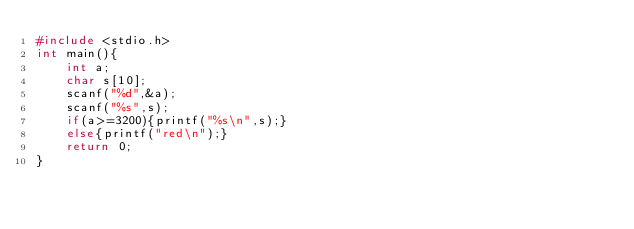<code> <loc_0><loc_0><loc_500><loc_500><_C_>#include <stdio.h>
int main(){
    int a;
    char s[10];
    scanf("%d",&a);
    scanf("%s",s);
    if(a>=3200){printf("%s\n",s);}
    else{printf("red\n");}
    return 0;
}</code> 